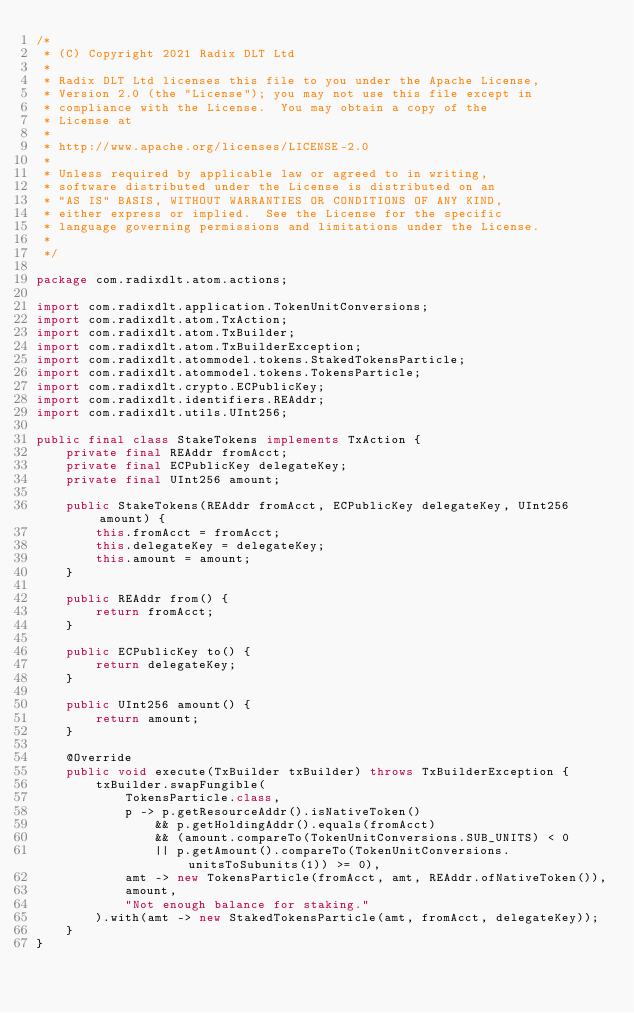<code> <loc_0><loc_0><loc_500><loc_500><_Java_>/*
 * (C) Copyright 2021 Radix DLT Ltd
 *
 * Radix DLT Ltd licenses this file to you under the Apache License,
 * Version 2.0 (the "License"); you may not use this file except in
 * compliance with the License.  You may obtain a copy of the
 * License at
 *
 * http://www.apache.org/licenses/LICENSE-2.0
 *
 * Unless required by applicable law or agreed to in writing,
 * software distributed under the License is distributed on an
 * "AS IS" BASIS, WITHOUT WARRANTIES OR CONDITIONS OF ANY KIND,
 * either express or implied.  See the License for the specific
 * language governing permissions and limitations under the License.
 *
 */

package com.radixdlt.atom.actions;

import com.radixdlt.application.TokenUnitConversions;
import com.radixdlt.atom.TxAction;
import com.radixdlt.atom.TxBuilder;
import com.radixdlt.atom.TxBuilderException;
import com.radixdlt.atommodel.tokens.StakedTokensParticle;
import com.radixdlt.atommodel.tokens.TokensParticle;
import com.radixdlt.crypto.ECPublicKey;
import com.radixdlt.identifiers.REAddr;
import com.radixdlt.utils.UInt256;

public final class StakeTokens implements TxAction {
	private final REAddr fromAcct;
	private final ECPublicKey delegateKey;
	private final UInt256 amount;

	public StakeTokens(REAddr fromAcct, ECPublicKey delegateKey, UInt256 amount) {
		this.fromAcct = fromAcct;
		this.delegateKey = delegateKey;
		this.amount = amount;
	}

	public REAddr from() {
		return fromAcct;
	}

	public ECPublicKey to() {
		return delegateKey;
	}

	public UInt256 amount() {
		return amount;
	}

	@Override
	public void execute(TxBuilder txBuilder) throws TxBuilderException {
		txBuilder.swapFungible(
			TokensParticle.class,
			p -> p.getResourceAddr().isNativeToken()
				&& p.getHoldingAddr().equals(fromAcct)
				&& (amount.compareTo(TokenUnitConversions.SUB_UNITS) < 0
				|| p.getAmount().compareTo(TokenUnitConversions.unitsToSubunits(1)) >= 0),
			amt -> new TokensParticle(fromAcct, amt, REAddr.ofNativeToken()),
			amount,
			"Not enough balance for staking."
		).with(amt -> new StakedTokensParticle(amt, fromAcct, delegateKey));
	}
}
</code> 